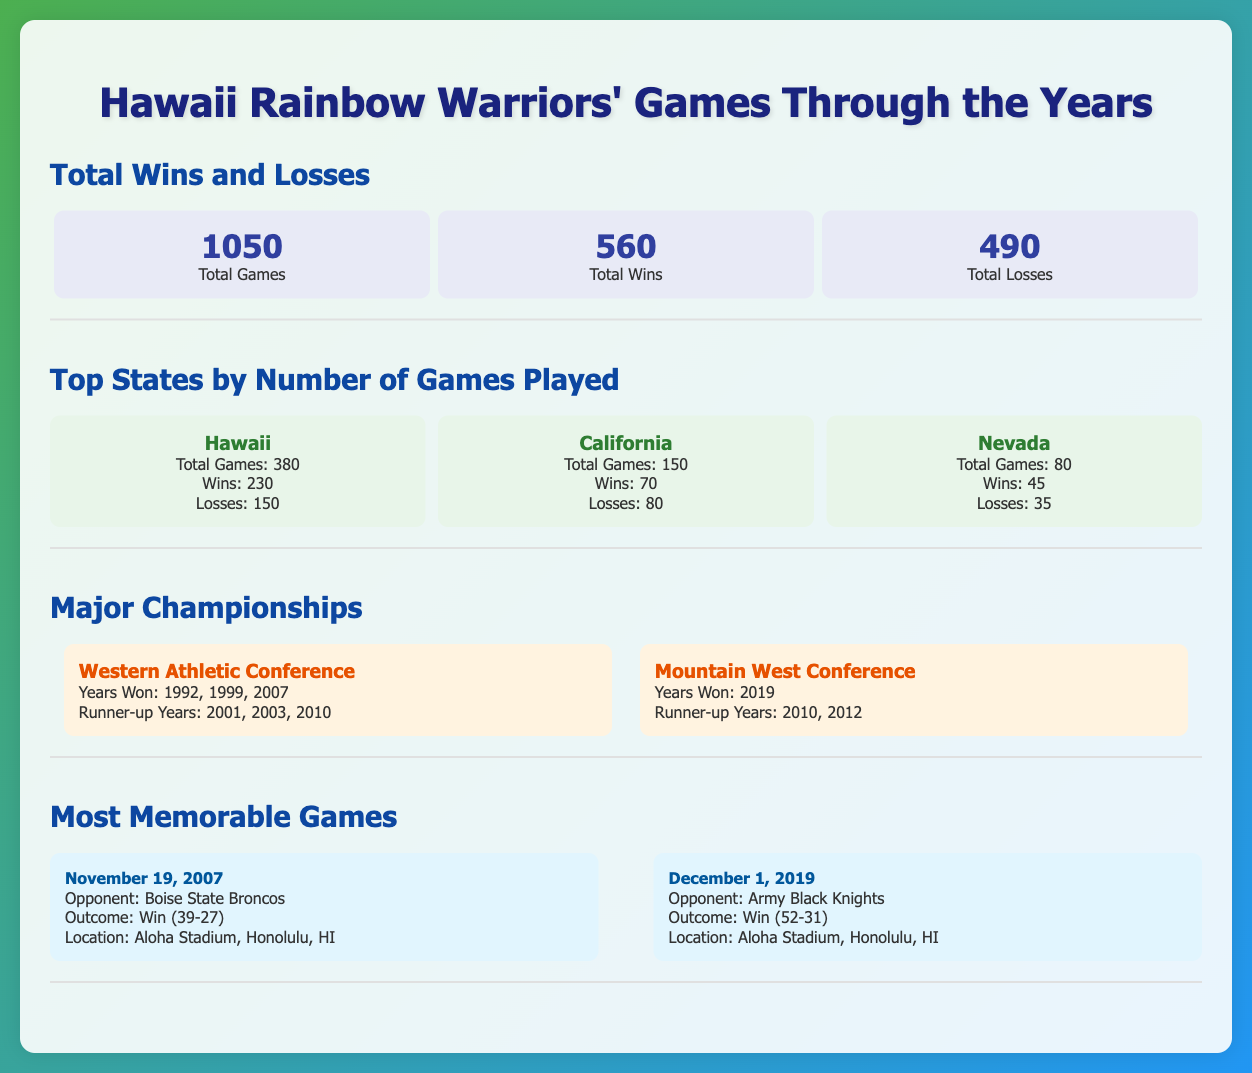What is the total number of games played by the Hawaii Rainbow Warriors? The total number of games is presented in the document as 1050.
Answer: 1050 How many total wins have the Hawaii Rainbow Warriors achieved? The total number of wins is listed in the document as 560.
Answer: 560 Which state has the highest total games played by the Hawaii Rainbow Warriors? The document specifies that Hawaii has the highest number of games played at 380.
Answer: Hawaii What year did the Hawaii Rainbow Warriors win the Mountain West Conference? The document states that they won the Mountain West Conference in 2019.
Answer: 2019 How many losses did the Hawaii Rainbow Warriors incur in California? According to the document, the losses in California are 80.
Answer: 80 What was the outcome of the memorable game on November 19, 2007? The document indicates the outcome as a win against Boise State Broncos with a score of 39-27.
Answer: Win (39-27) How many championships did the Hawaii Rainbow Warriors win in the Western Athletic Conference? The document lists the wins in the Western Athletic Conference as 3.
Answer: 3 What is the total number of games played in Nevada? The total games played in Nevada is mentioned as 80 in the document.
Answer: 80 Which opponent did the Hawaii Rainbow Warriors face on December 1, 2019? The document details that the opponent was Army Black Knights.
Answer: Army Black Knights 